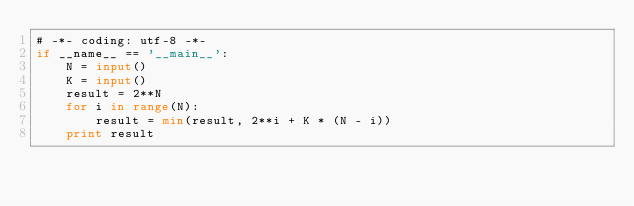Convert code to text. <code><loc_0><loc_0><loc_500><loc_500><_Python_># -*- coding: utf-8 -*-
if __name__ == '__main__':
    N = input()
    K = input()
    result = 2**N
    for i in range(N):
        result = min(result, 2**i + K * (N - i))
    print result
</code> 